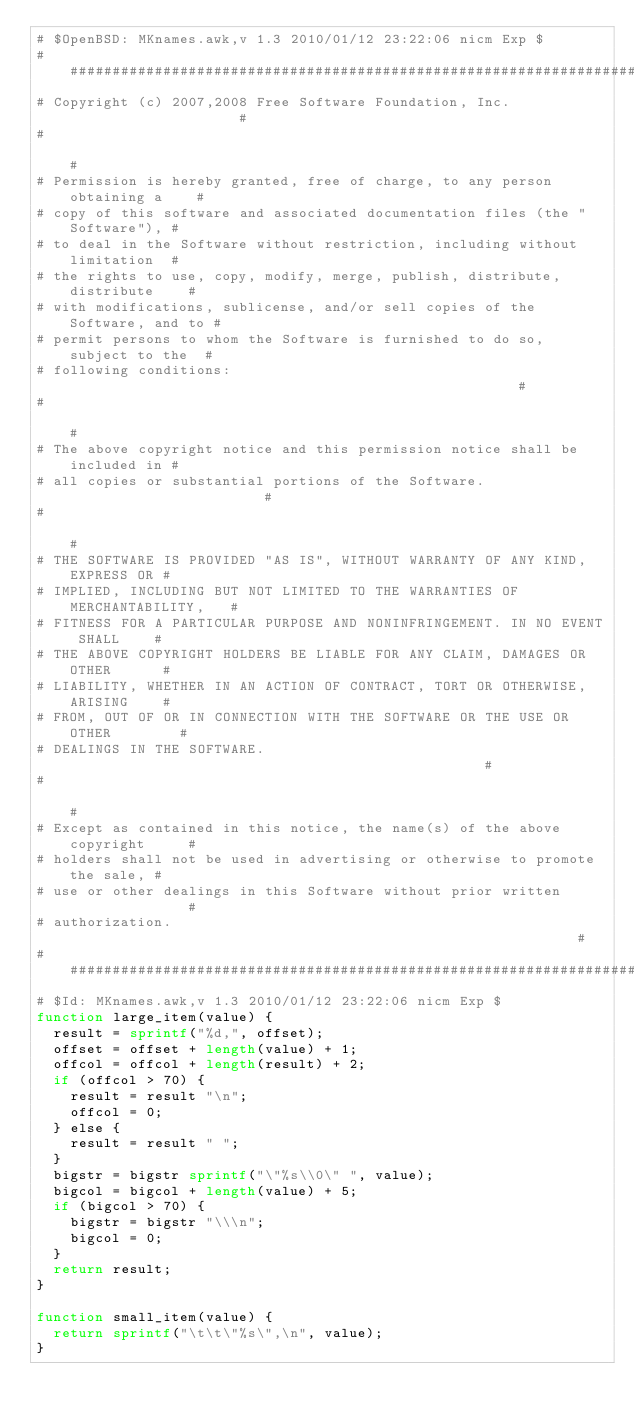<code> <loc_0><loc_0><loc_500><loc_500><_Awk_># $OpenBSD: MKnames.awk,v 1.3 2010/01/12 23:22:06 nicm Exp $
##############################################################################
# Copyright (c) 2007,2008 Free Software Foundation, Inc.                     #
#                                                                            #
# Permission is hereby granted, free of charge, to any person obtaining a    #
# copy of this software and associated documentation files (the "Software"), #
# to deal in the Software without restriction, including without limitation  #
# the rights to use, copy, modify, merge, publish, distribute, distribute    #
# with modifications, sublicense, and/or sell copies of the Software, and to #
# permit persons to whom the Software is furnished to do so, subject to the  #
# following conditions:                                                      #
#                                                                            #
# The above copyright notice and this permission notice shall be included in #
# all copies or substantial portions of the Software.                        #
#                                                                            #
# THE SOFTWARE IS PROVIDED "AS IS", WITHOUT WARRANTY OF ANY KIND, EXPRESS OR #
# IMPLIED, INCLUDING BUT NOT LIMITED TO THE WARRANTIES OF MERCHANTABILITY,   #
# FITNESS FOR A PARTICULAR PURPOSE AND NONINFRINGEMENT. IN NO EVENT SHALL    #
# THE ABOVE COPYRIGHT HOLDERS BE LIABLE FOR ANY CLAIM, DAMAGES OR OTHER      #
# LIABILITY, WHETHER IN AN ACTION OF CONTRACT, TORT OR OTHERWISE, ARISING    #
# FROM, OUT OF OR IN CONNECTION WITH THE SOFTWARE OR THE USE OR OTHER        #
# DEALINGS IN THE SOFTWARE.                                                  #
#                                                                            #
# Except as contained in this notice, the name(s) of the above copyright     #
# holders shall not be used in advertising or otherwise to promote the sale, #
# use or other dealings in this Software without prior written               #
# authorization.                                                             #
##############################################################################
# $Id: MKnames.awk,v 1.3 2010/01/12 23:22:06 nicm Exp $
function large_item(value) {
	result = sprintf("%d,", offset);
	offset = offset + length(value) + 1;
	offcol = offcol + length(result) + 2;
	if (offcol > 70) {
		result = result "\n";
		offcol = 0;
	} else {
		result = result " ";
	}
	bigstr = bigstr sprintf("\"%s\\0\" ", value);
	bigcol = bigcol + length(value) + 5;
	if (bigcol > 70) {
		bigstr = bigstr "\\\n";
		bigcol = 0;
	}
	return result;
}

function small_item(value) {
	return sprintf("\t\t\"%s\",\n", value);
}
</code> 